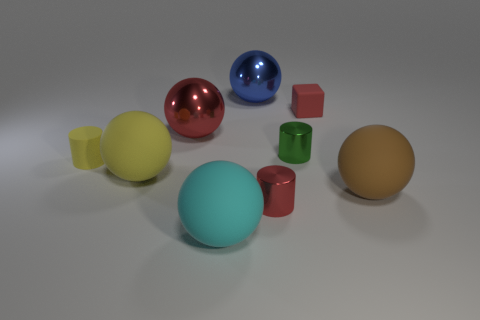How many other things are there of the same shape as the large cyan matte object?
Provide a short and direct response. 4. The red object that is the same material as the large red sphere is what shape?
Provide a succinct answer. Cylinder. What number of tiny things are either brown spheres or red rubber objects?
Offer a terse response. 1. How many other objects are there of the same color as the rubber block?
Your answer should be very brief. 2. There is a metallic cylinder that is in front of the rubber sphere that is left of the cyan rubber object; what number of objects are behind it?
Ensure brevity in your answer.  7. There is a red metal object that is to the left of the red cylinder; does it have the same size as the large yellow thing?
Your response must be concise. Yes. Is the number of large brown balls that are behind the matte block less than the number of yellow matte objects that are right of the big red shiny ball?
Give a very brief answer. No. Do the small cube and the small rubber cylinder have the same color?
Keep it short and to the point. No. Are there fewer red metallic cylinders that are on the left side of the red shiny sphere than yellow matte balls?
Offer a very short reply. Yes. There is a big object that is the same color as the tiny block; what is its material?
Your response must be concise. Metal. 